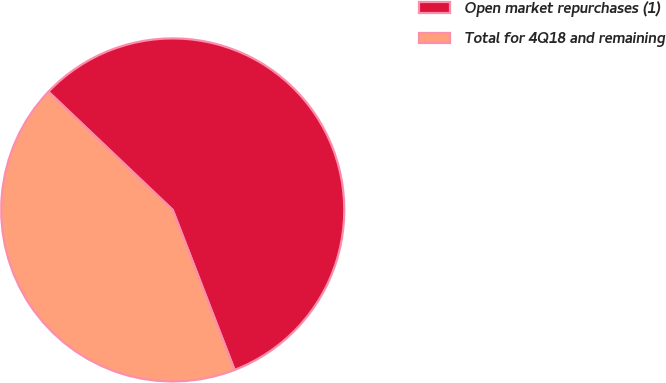Convert chart to OTSL. <chart><loc_0><loc_0><loc_500><loc_500><pie_chart><fcel>Open market repurchases (1)<fcel>Total for 4Q18 and remaining<nl><fcel>57.03%<fcel>42.97%<nl></chart> 